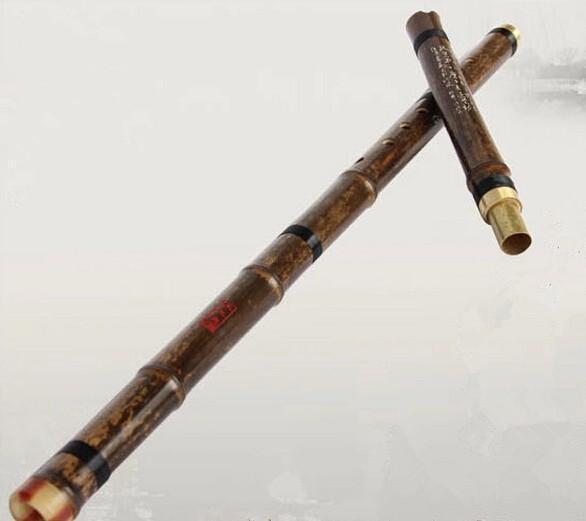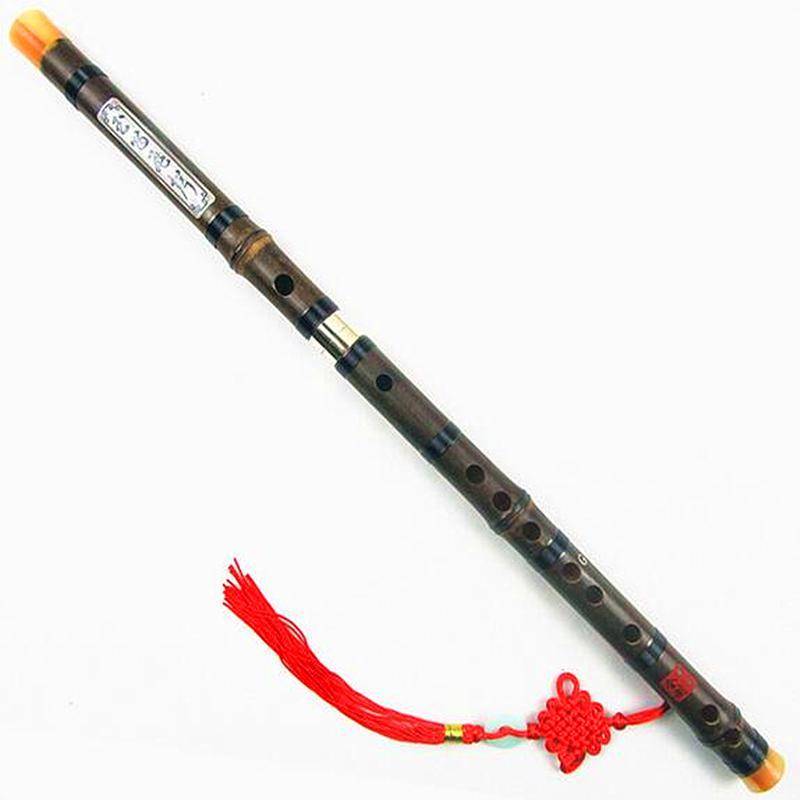The first image is the image on the left, the second image is the image on the right. Given the left and right images, does the statement "One of the instruments is taken apart into two separate pieces." hold true? Answer yes or no. Yes. The first image is the image on the left, the second image is the image on the right. Given the left and right images, does the statement "The left image shows two overlapping, criss-crossed flute parts, and the right image shows at least one flute displayed diagonally." hold true? Answer yes or no. Yes. 